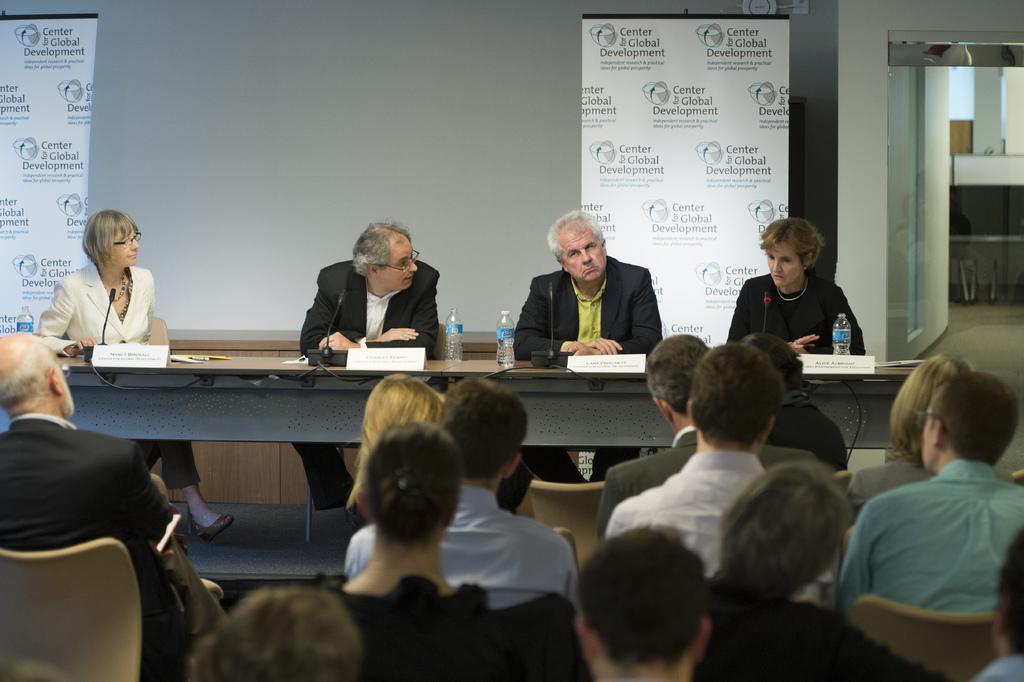In one or two sentences, can you explain what this image depicts? In this picture there are four people sitting on the Dais with the the microphones in front of them that water bottle and they have some audience and in the background as a banner 